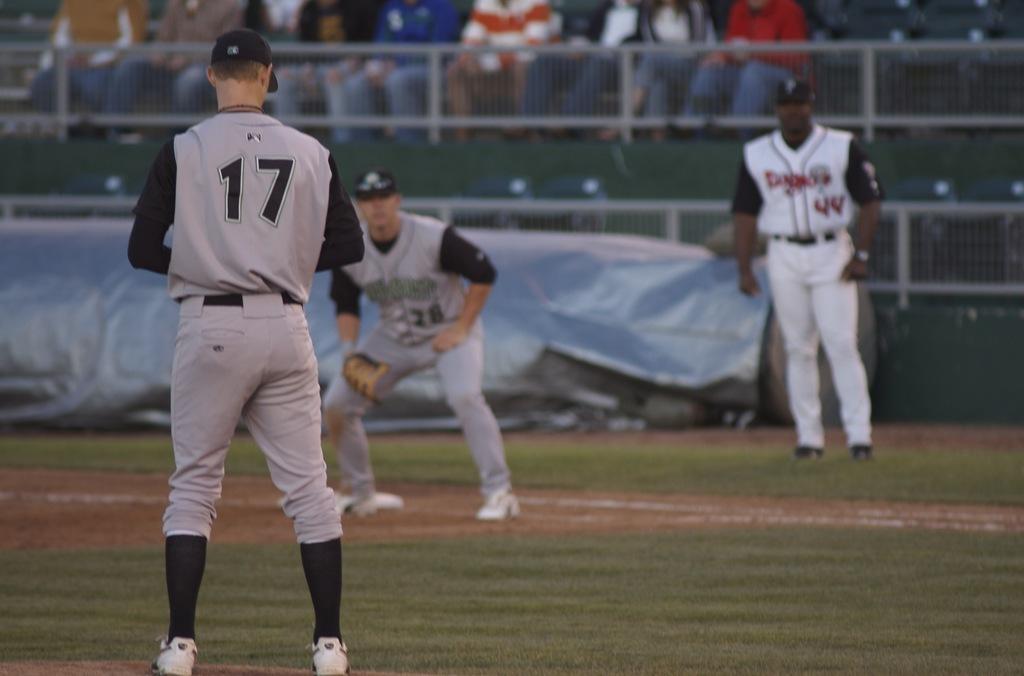What jersey number is the pitcher?
Your answer should be compact. 17. What number is the first baseman?
Your answer should be compact. 28. 